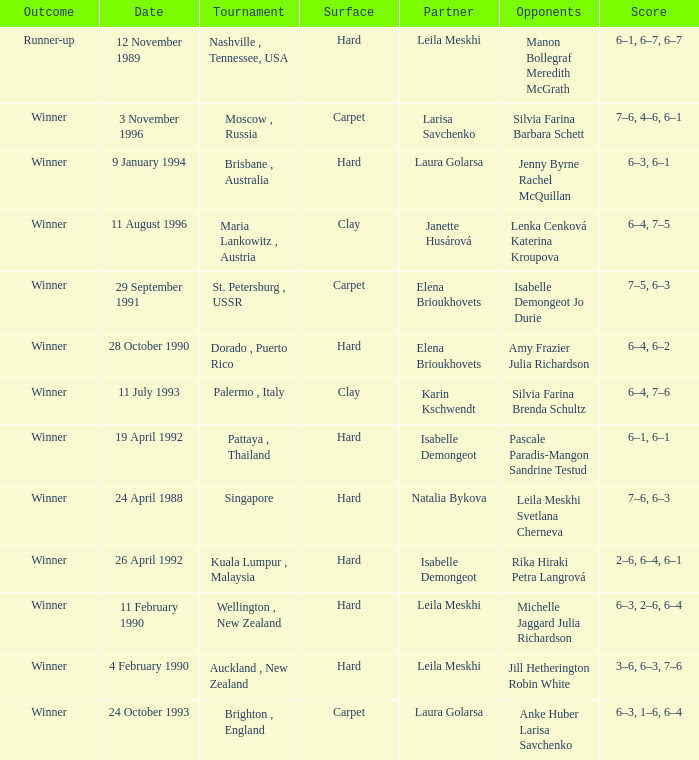On what Date was the Score 6–4, 6–2? 28 October 1990. 